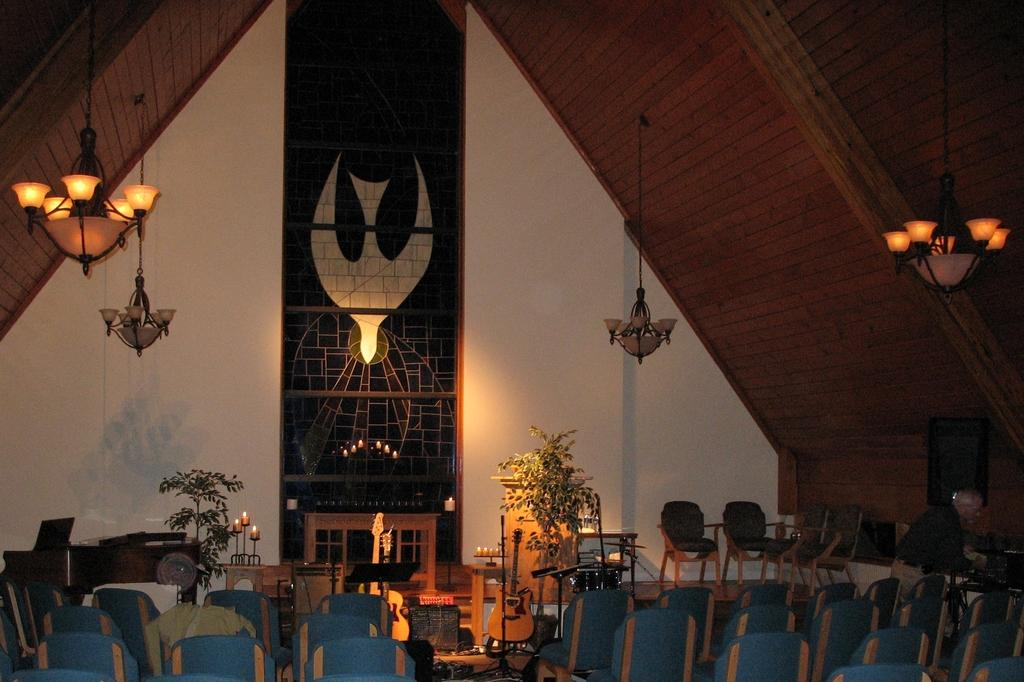What type of furniture can be seen in the image? There are chairs in the image. What other objects are present in the image? There are plants, tables, and candles visible in the image. What is the structure above the objects in the image? There is a roof visible in the image. What type of illumination is present in the image? There are lights in the image. What is in the background of the image? There is a wall in the background of the image. What rhythm do the birds in the image follow? There are no birds present in the image, so there is no rhythm to follow. What is the price of the candles in the image? The price of the candles is not visible in the image, so it cannot be determined. 